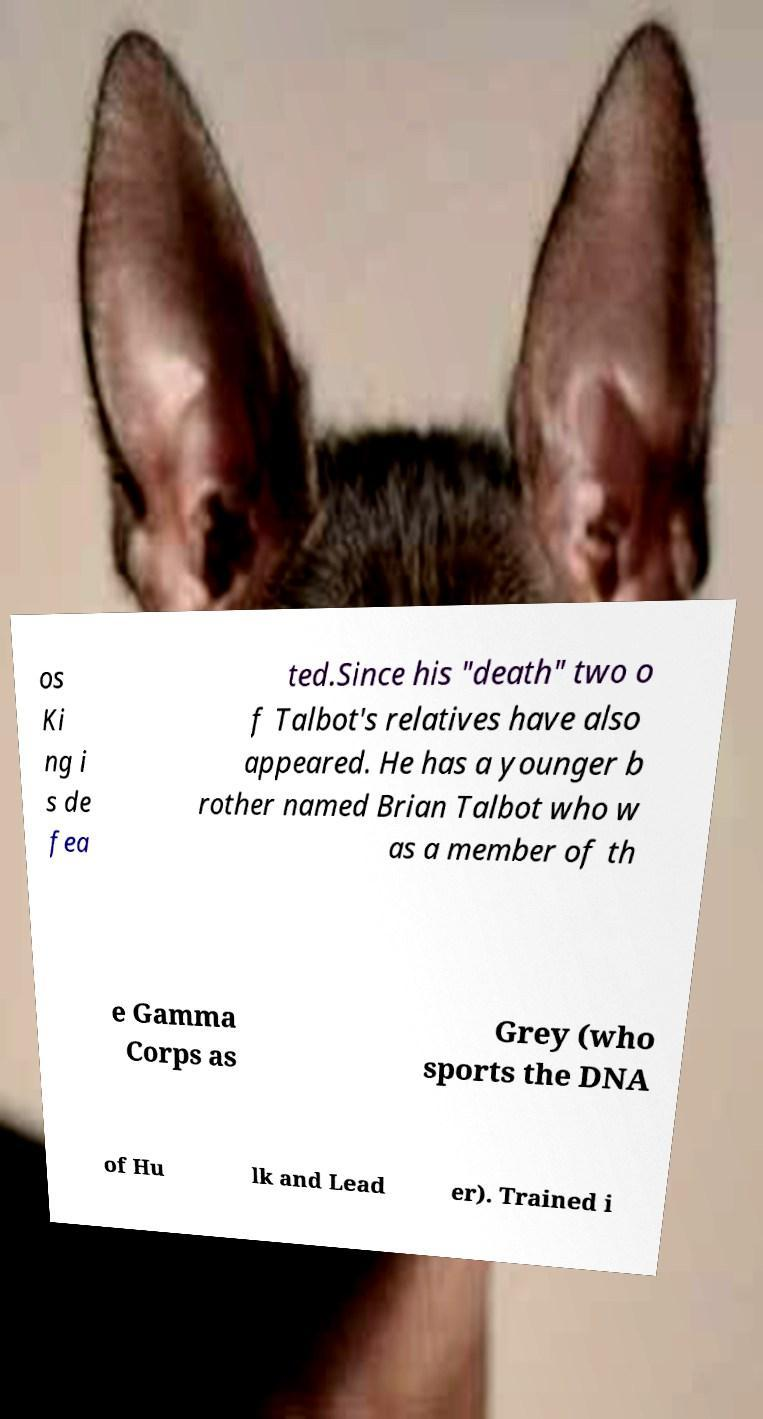There's text embedded in this image that I need extracted. Can you transcribe it verbatim? os Ki ng i s de fea ted.Since his "death" two o f Talbot's relatives have also appeared. He has a younger b rother named Brian Talbot who w as a member of th e Gamma Corps as Grey (who sports the DNA of Hu lk and Lead er). Trained i 